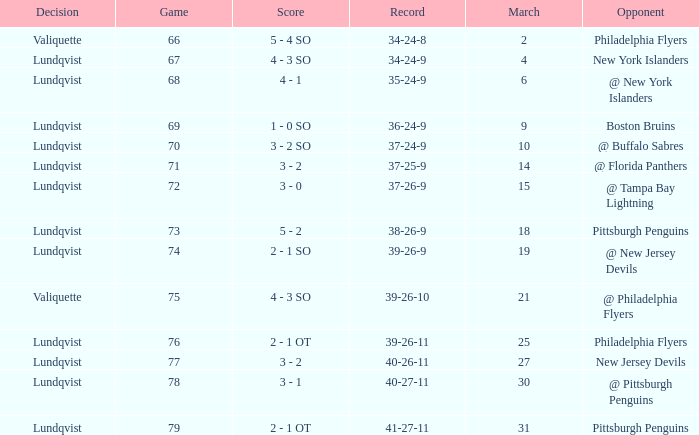Which opponent's march was 31? Pittsburgh Penguins. 